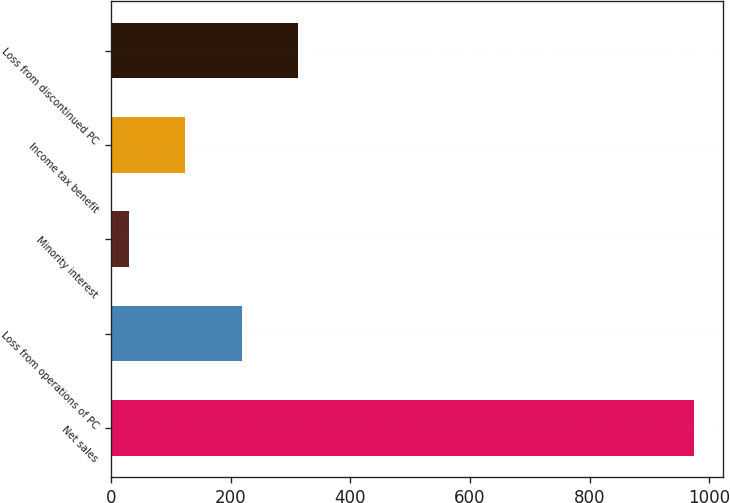<chart> <loc_0><loc_0><loc_500><loc_500><bar_chart><fcel>Net sales<fcel>Loss from operations of PC<fcel>Minority interest<fcel>Income tax benefit<fcel>Loss from discontinued PC<nl><fcel>973.9<fcel>218.14<fcel>29.2<fcel>123.67<fcel>312.61<nl></chart> 